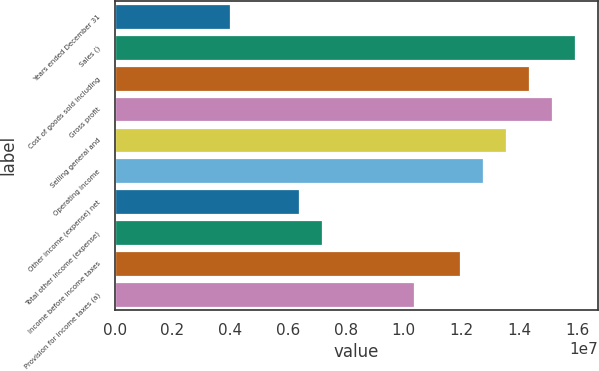Convert chart to OTSL. <chart><loc_0><loc_0><loc_500><loc_500><bar_chart><fcel>Years ended December 31<fcel>Sales ()<fcel>Cost of goods sold including<fcel>Gross profit<fcel>Selling general and<fcel>Operating income<fcel>Other income (expense) net<fcel>Total other income (expense)<fcel>Income before income taxes<fcel>Provision for income taxes (a)<nl><fcel>3.98334e+06<fcel>1.59333e+07<fcel>1.434e+07<fcel>1.51367e+07<fcel>1.35433e+07<fcel>1.27467e+07<fcel>6.37334e+06<fcel>7.17001e+06<fcel>1.195e+07<fcel>1.03567e+07<nl></chart> 